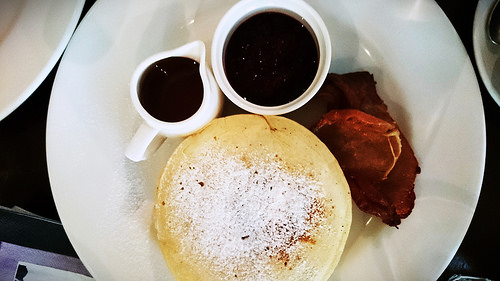<image>
Is there a syrup next to the pancake? Yes. The syrup is positioned adjacent to the pancake, located nearby in the same general area. 